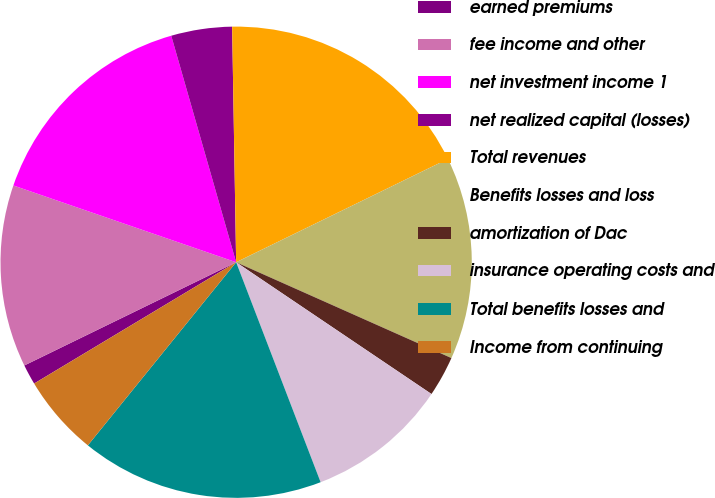<chart> <loc_0><loc_0><loc_500><loc_500><pie_chart><fcel>earned premiums<fcel>fee income and other<fcel>net investment income 1<fcel>net realized capital (losses)<fcel>Total revenues<fcel>Benefits losses and loss<fcel>amortization of Dac<fcel>insurance operating costs and<fcel>Total benefits losses and<fcel>Income from continuing<nl><fcel>1.39%<fcel>12.5%<fcel>15.28%<fcel>4.17%<fcel>18.05%<fcel>13.89%<fcel>2.78%<fcel>9.72%<fcel>16.67%<fcel>5.56%<nl></chart> 